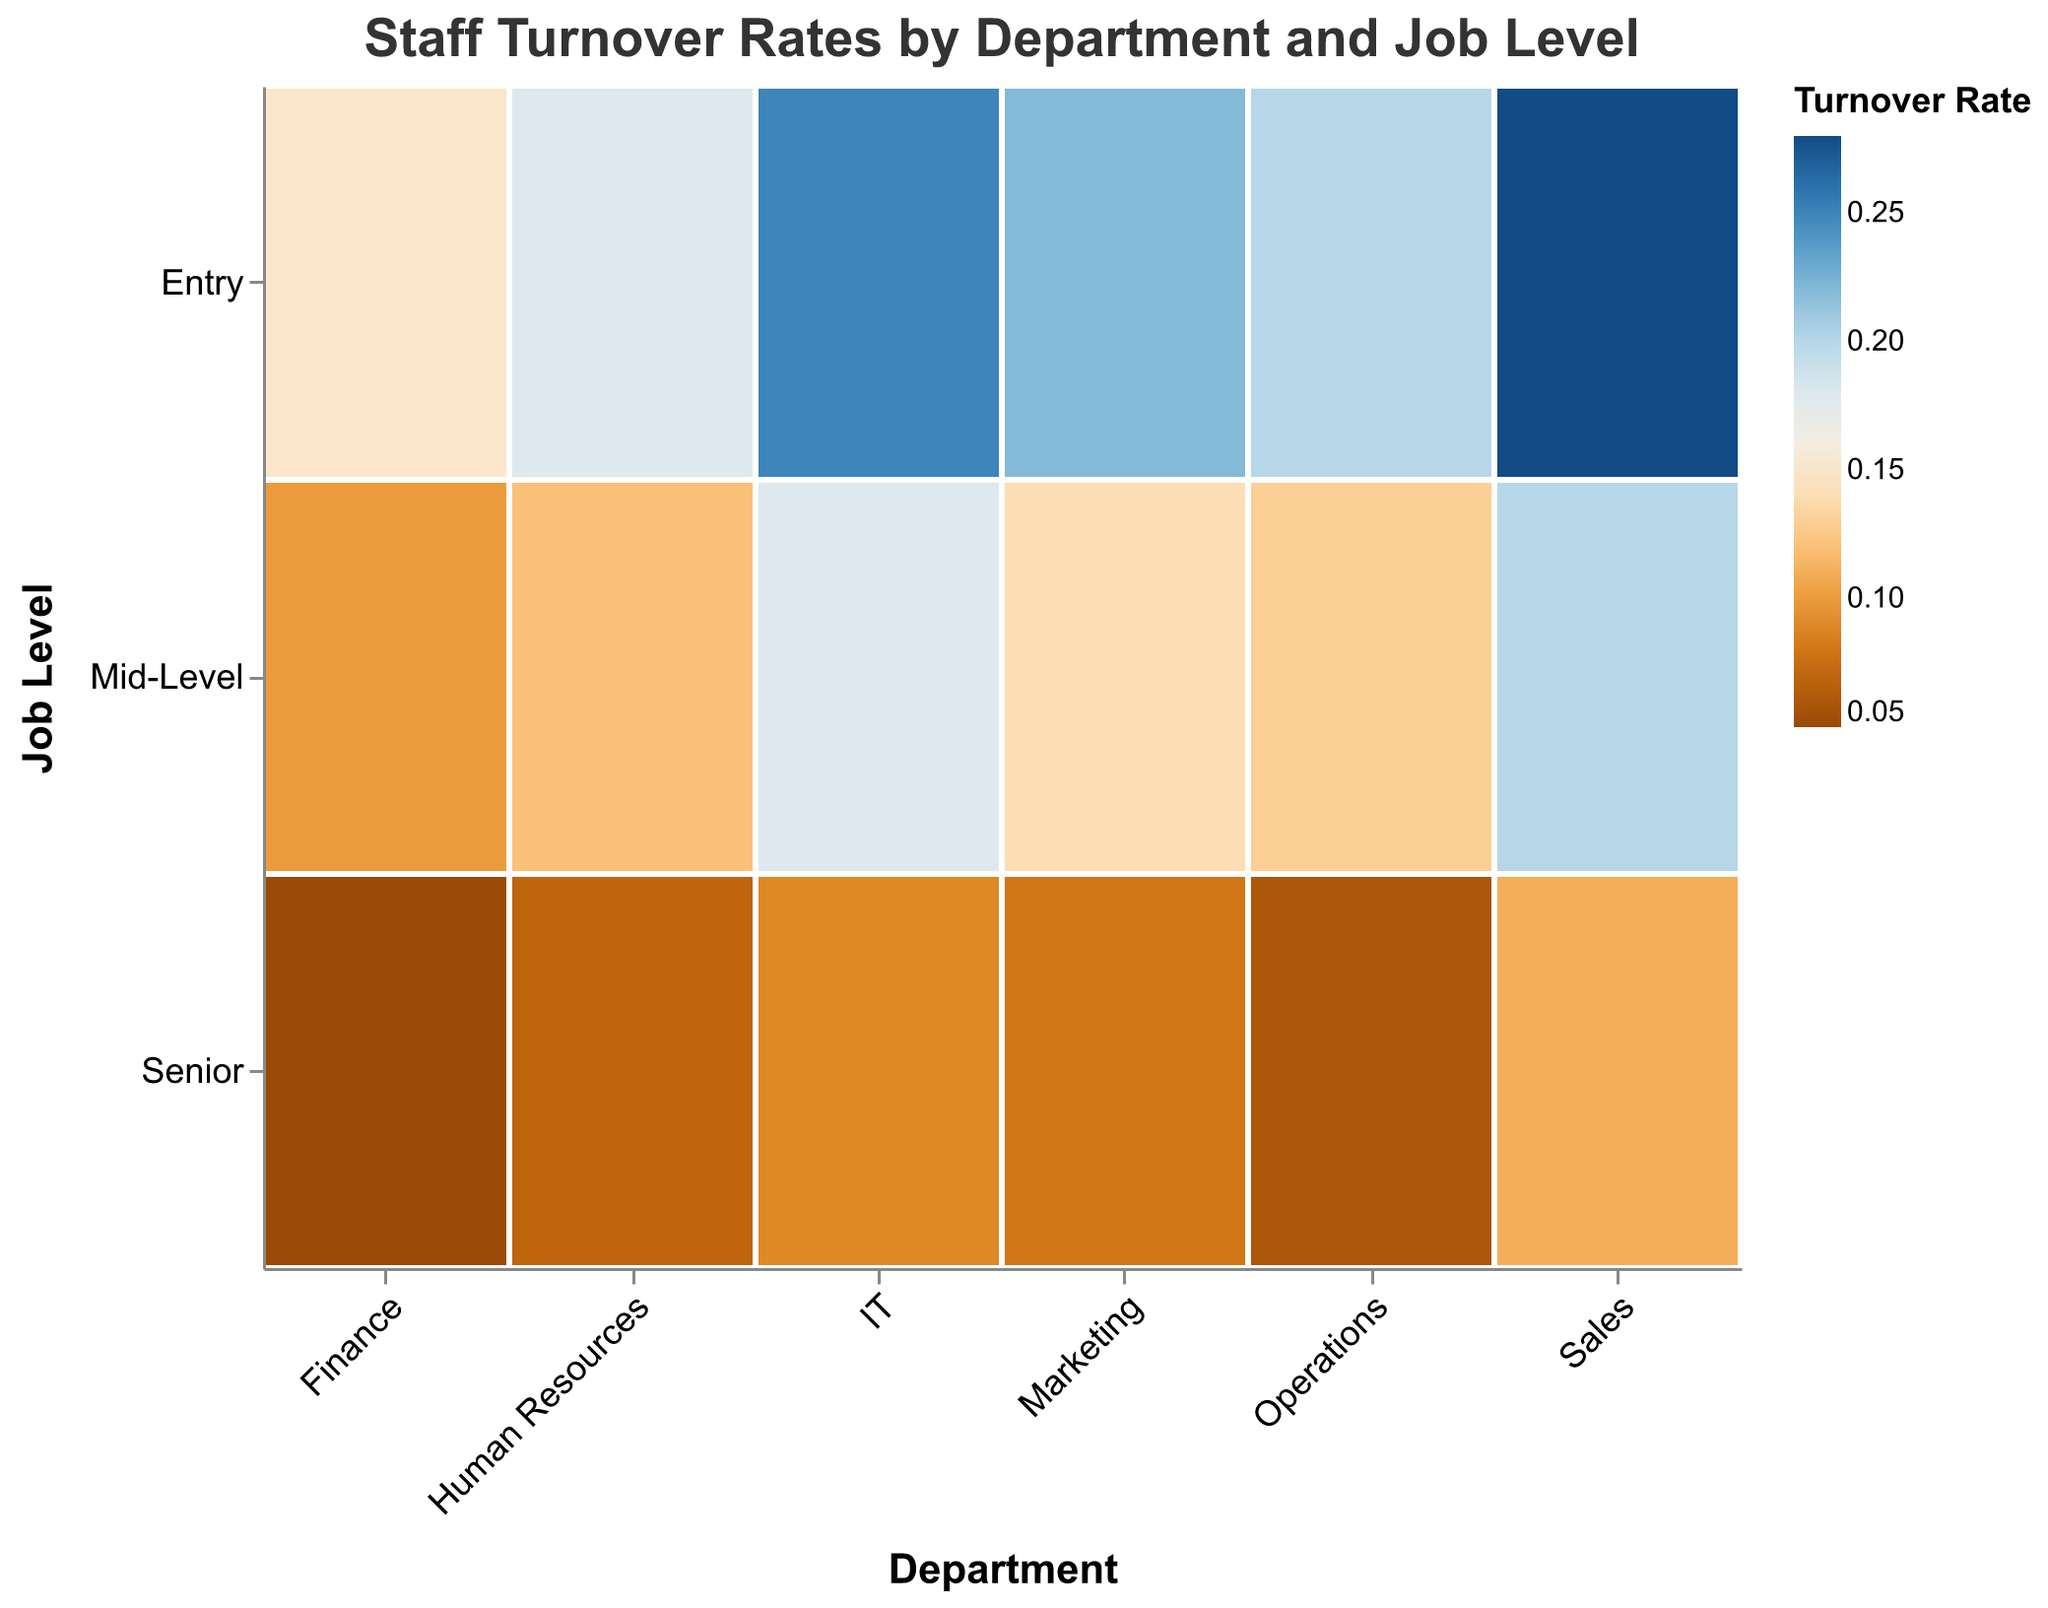What's the title of the plot? The plot title is located at the top of the figure and reads "Staff Turnover Rates by Department and Job Level".
Answer: Staff Turnover Rates by Department and Job Level Which department has the highest turnover rate at the entry job level? By looking at the color intensity and finding the darkest shade among the "Entry" job level categories, IT has the highest turnover rate with a value of 25%.
Answer: IT What's the difference in turnover rates between Entry and Senior levels in the Sales department? The Sales department has a 28% turnover rate at the Entry level and 11% at the Senior level. The difference is calculated as 28% - 11%.
Answer: 17% Which department has the lowest turnover rate at the Senior job level? The lowest turnover rate at the Senior job level corresponds to the lightest shade in the "Senior" category, which is 5% in the Finance department.
Answer: Finance How does the turnover rate for Mid-Level employees in Marketing compare to those in IT? The turnover rate for Mid-Level employees in Marketing is 14%, whereas in IT it is 18%. Therefore, Marketing has a lower turnover rate than IT by 4%.
Answer: Marketing has 4% lower Are entry-level employees in Operations or Marketing experiencing higher turnover rates? The turnover rate for Entry-Level employees in Operations is 20%, while in Marketing it is 22%. Therefore, Marketing has a higher turnover rate.
Answer: Marketing What is the average turnover rate for Senior job levels across all departments? The turnover rates for Senior job levels are: Human Resources (7%), Finance (5%), Marketing (8%), Operations (6%), IT (9%), and Sales (11%). The average is calculated as (7 + 5 + 8 + 6 + 9 + 11) / 6.
Answer: 7.67% Compare the turnover rates between Entry and Mid-Level job levels in the Human Resources department. In Human Resources, the turnover rate at Entry level is 18% and at Mid-Level is 12%. The Entry level has a higher turnover rate by 6%.
Answer: Entry level is higher by 6% Which job level consistently experiences the lowest turnover rate across departments? By comparing the shades across job levels in multiple departments, the Senior level generally has the lightest shade, indicating the lowest turnover rate in most departments.
Answer: Senior What is the highest turnover rate observed in the plot and for which job level and department does it occur? The darkest region in the plot corresponds to the highest turnover rate, which is 28% for Entry level in the Sales department.
Answer: Entry level in Sales at 28% 